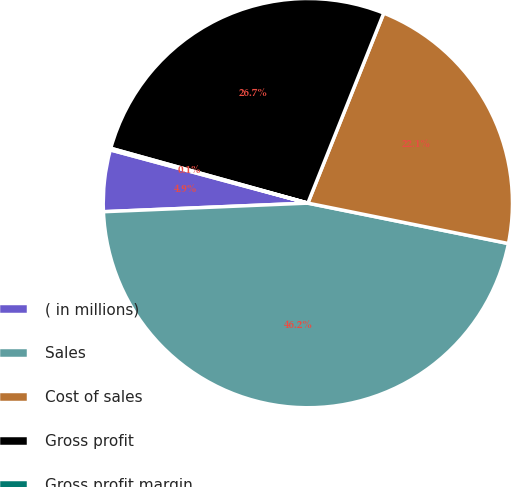Convert chart to OTSL. <chart><loc_0><loc_0><loc_500><loc_500><pie_chart><fcel>( in millions)<fcel>Sales<fcel>Cost of sales<fcel>Gross profit<fcel>Gross profit margin<nl><fcel>4.86%<fcel>46.17%<fcel>22.12%<fcel>26.73%<fcel>0.13%<nl></chart> 